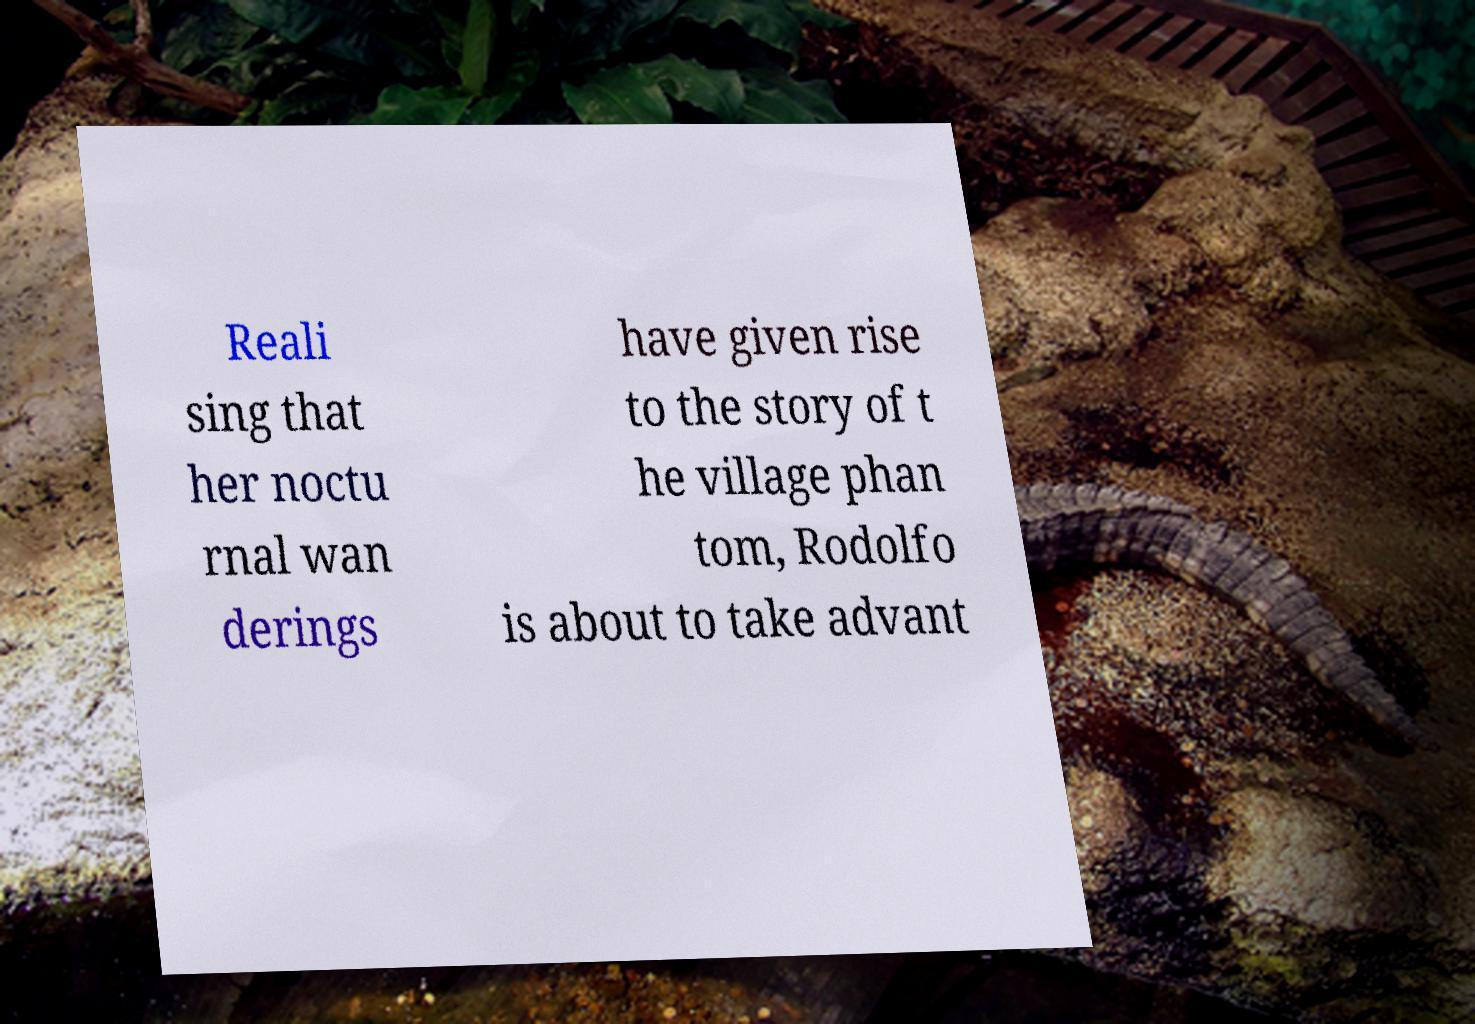What messages or text are displayed in this image? I need them in a readable, typed format. Reali sing that her noctu rnal wan derings have given rise to the story of t he village phan tom, Rodolfo is about to take advant 